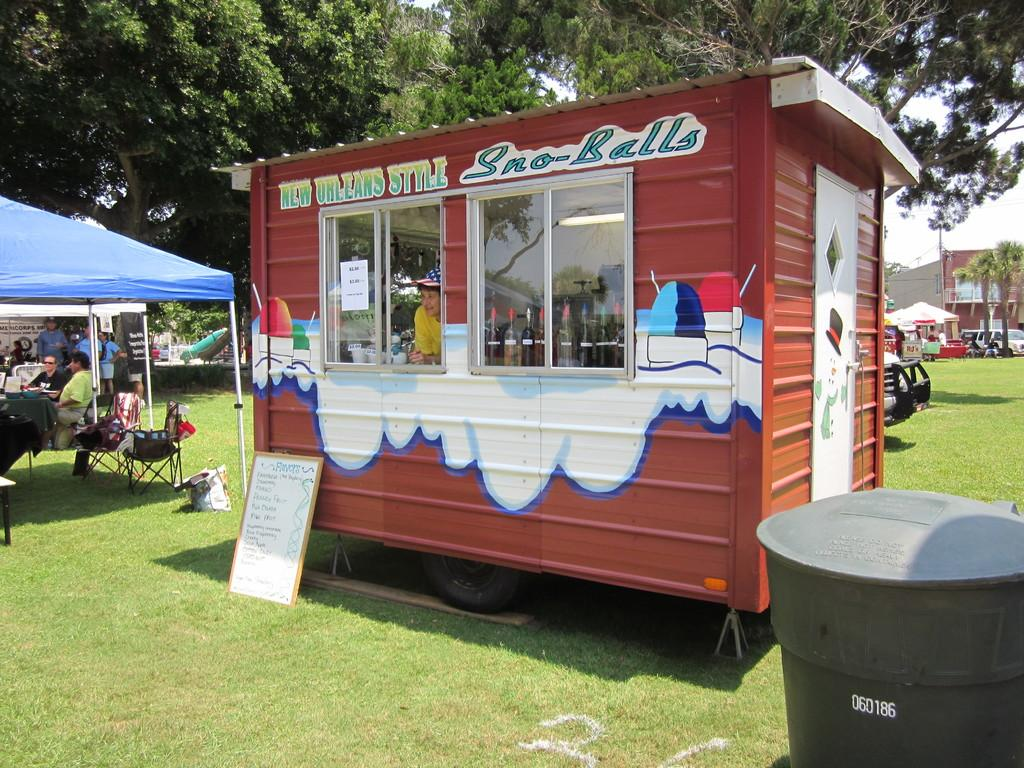<image>
Relay a brief, clear account of the picture shown. A small shack sells a treat called Sno-Balls. 